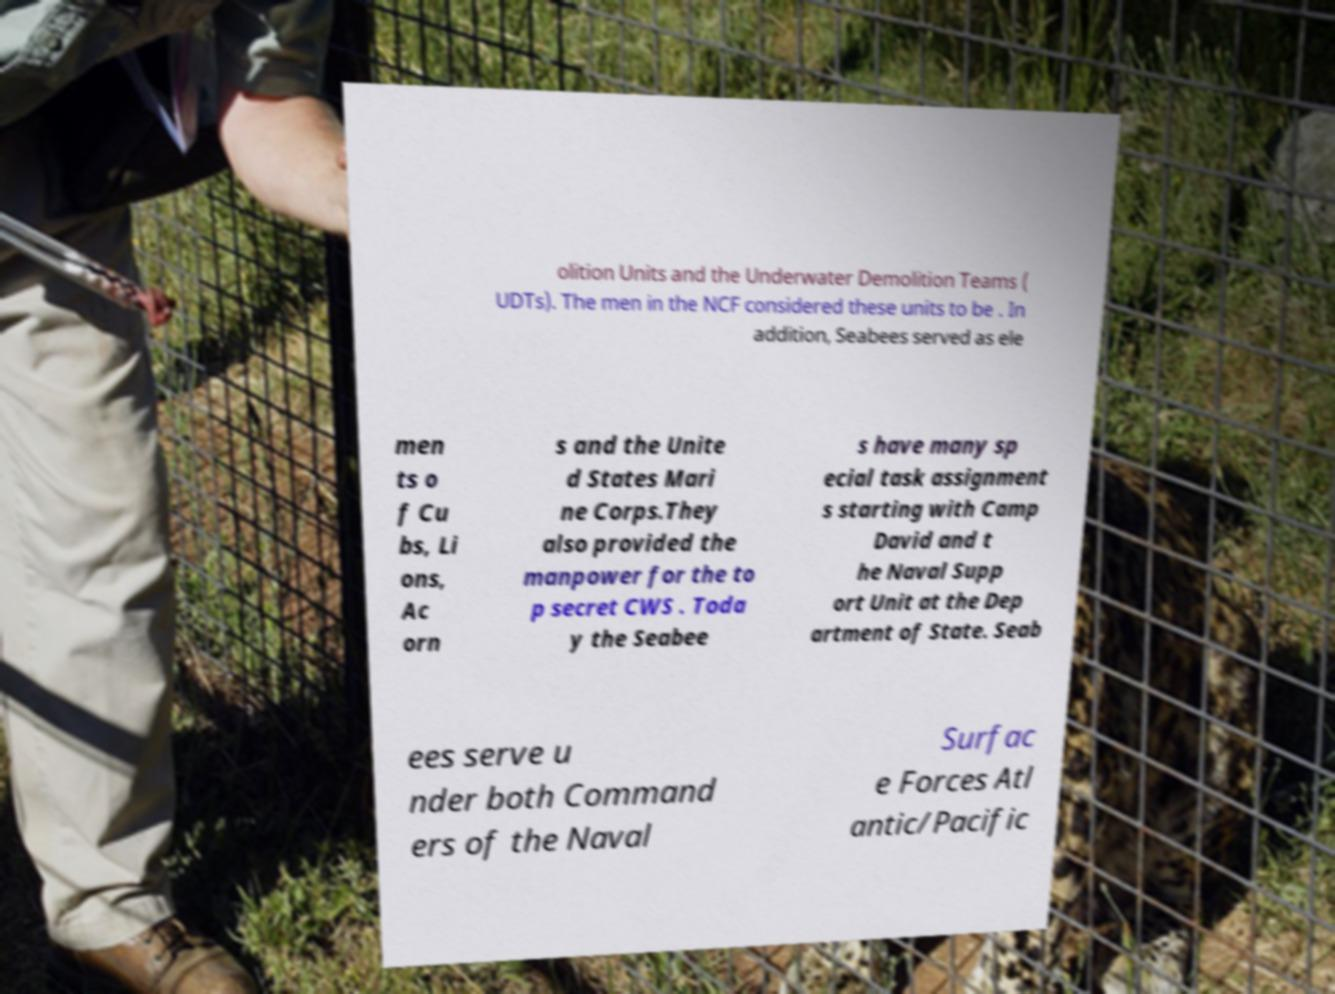Can you accurately transcribe the text from the provided image for me? olition Units and the Underwater Demolition Teams ( UDTs). The men in the NCF considered these units to be . In addition, Seabees served as ele men ts o f Cu bs, Li ons, Ac orn s and the Unite d States Mari ne Corps.They also provided the manpower for the to p secret CWS . Toda y the Seabee s have many sp ecial task assignment s starting with Camp David and t he Naval Supp ort Unit at the Dep artment of State. Seab ees serve u nder both Command ers of the Naval Surfac e Forces Atl antic/Pacific 